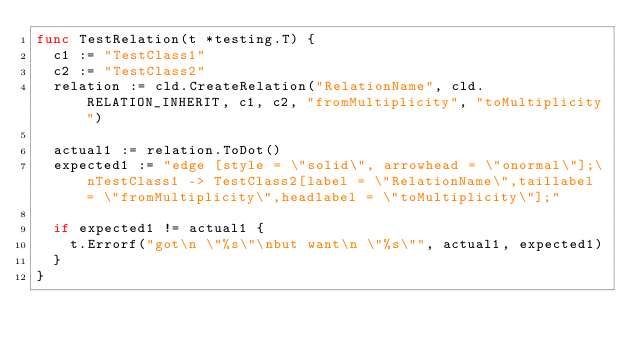Convert code to text. <code><loc_0><loc_0><loc_500><loc_500><_Go_>func TestRelation(t *testing.T) {
	c1 := "TestClass1"
	c2 := "TestClass2"
	relation := cld.CreateRelation("RelationName", cld.RELATION_INHERIT, c1, c2, "fromMultiplicity", "toMultiplicity")

	actual1 := relation.ToDot()
	expected1 := "edge [style = \"solid\", arrowhead = \"onormal\"];\nTestClass1 -> TestClass2[label = \"RelationName\",taillabel = \"fromMultiplicity\",headlabel = \"toMultiplicity\"];"

	if expected1 != actual1 {
		t.Errorf("got\n \"%s\"\nbut want\n \"%s\"", actual1, expected1)
	}
}
</code> 